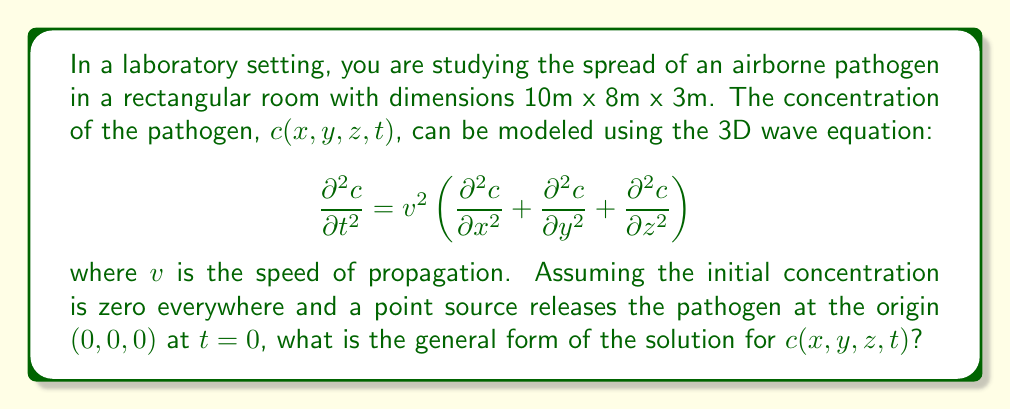What is the answer to this math problem? To solve this problem, we'll follow these steps:

1) The 3D wave equation with a point source at the origin can be solved using the method of Green's functions.

2) The Green's function for the 3D wave equation in free space is:

   $$G(x,y,z,t) = \frac{\delta(vt - r)}{4\pi r}$$

   where $r = \sqrt{x^2 + y^2 + z^2}$ is the distance from the origin, and $\delta$ is the Dirac delta function.

3) For a point source at the origin, the solution can be expressed as:

   $$c(x,y,z,t) = \frac{Q}{4\pi r} \delta(vt - r)$$

   where $Q$ is the strength of the source.

4) However, we need to account for the reflections from the walls of the room. This can be done using the method of images, where we add virtual sources outside the room to satisfy the boundary conditions.

5) The general solution will be a superposition of the direct wave and all its reflections:

   $$c(x,y,z,t) = \frac{Q}{4\pi} \sum_{i,j,k=-\infty}^{\infty} \frac{\delta(vt - r_{ijk})}{r_{ijk}}$$

   where $r_{ijk} = \sqrt{(x-2iL_x)^2 + (y-2jL_y)^2 + (z-2kL_z)^2}$, and $L_x=10$m, $L_y=8$m, $L_z=3$m are the room dimensions.

6) This solution represents a series of spherical waves emanating from the source and its image sources, creating a complex interference pattern within the room.
Answer: $$c(x,y,z,t) = \frac{Q}{4\pi} \sum_{i,j,k=-\infty}^{\infty} \frac{\delta(vt - r_{ijk})}{r_{ijk}}$$ 